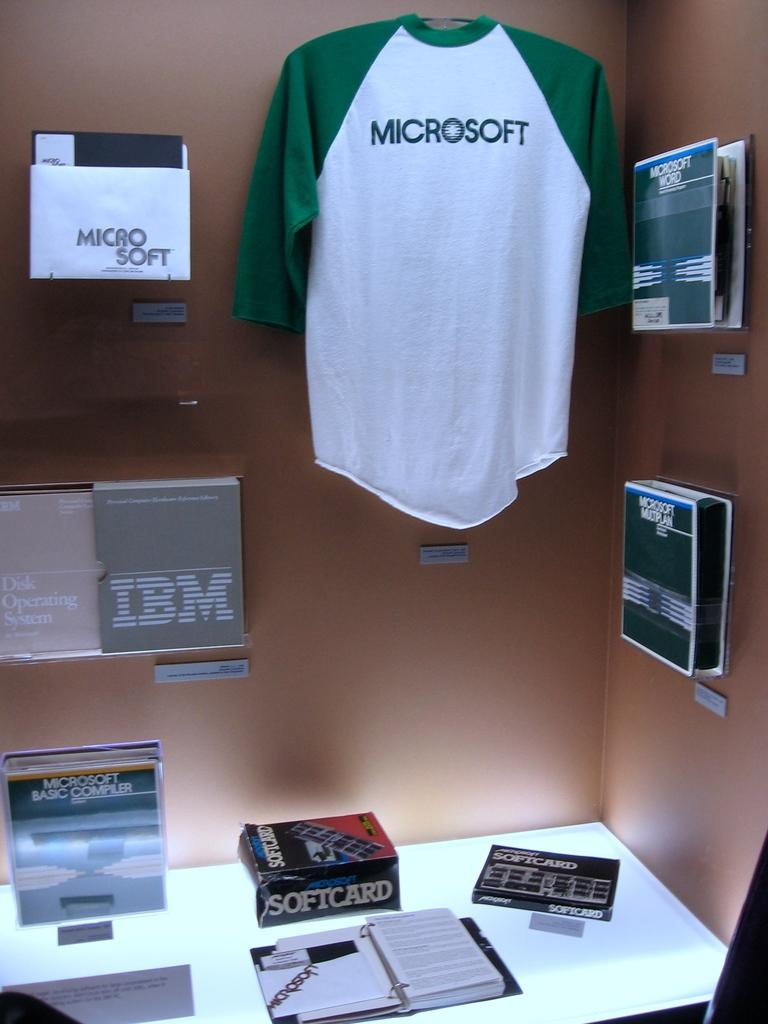Provide a one-sentence caption for the provided image. A display of different computer brands such as IBM and Microsoft. 